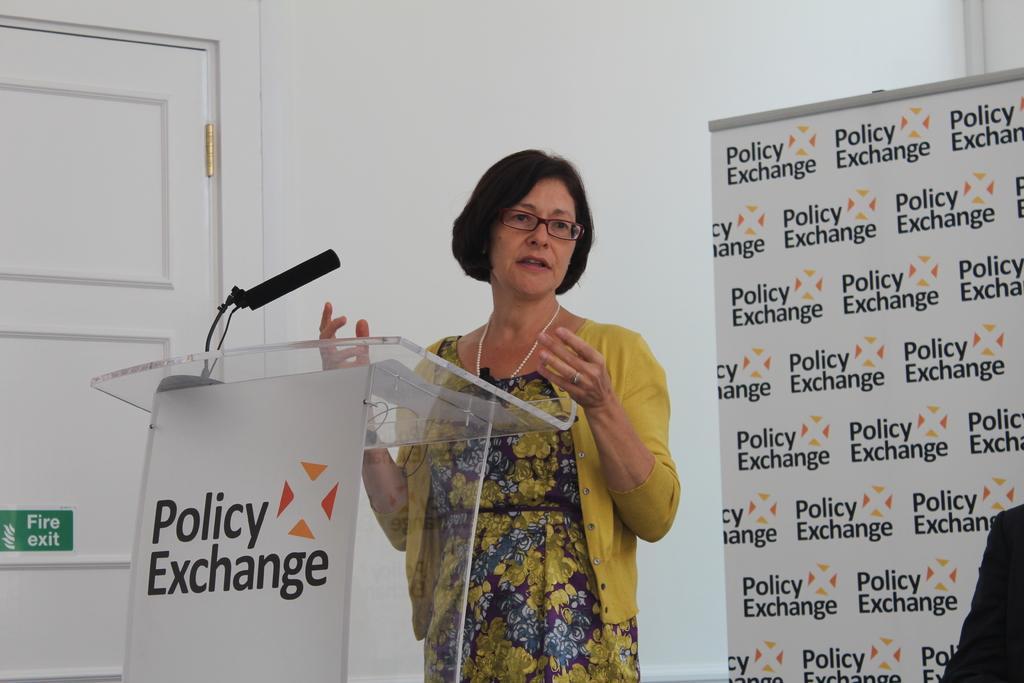Could you give a brief overview of what you see in this image? In this image we can see a woman standing in front of the podium, on the podium, we can see a mic and some text, also we can see a door, board with some text and the wall. 